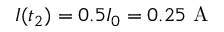<formula> <loc_0><loc_0><loc_500><loc_500>I ( t _ { 2 } ) = 0 . 5 I _ { 0 } = 0 . 2 5 A</formula> 